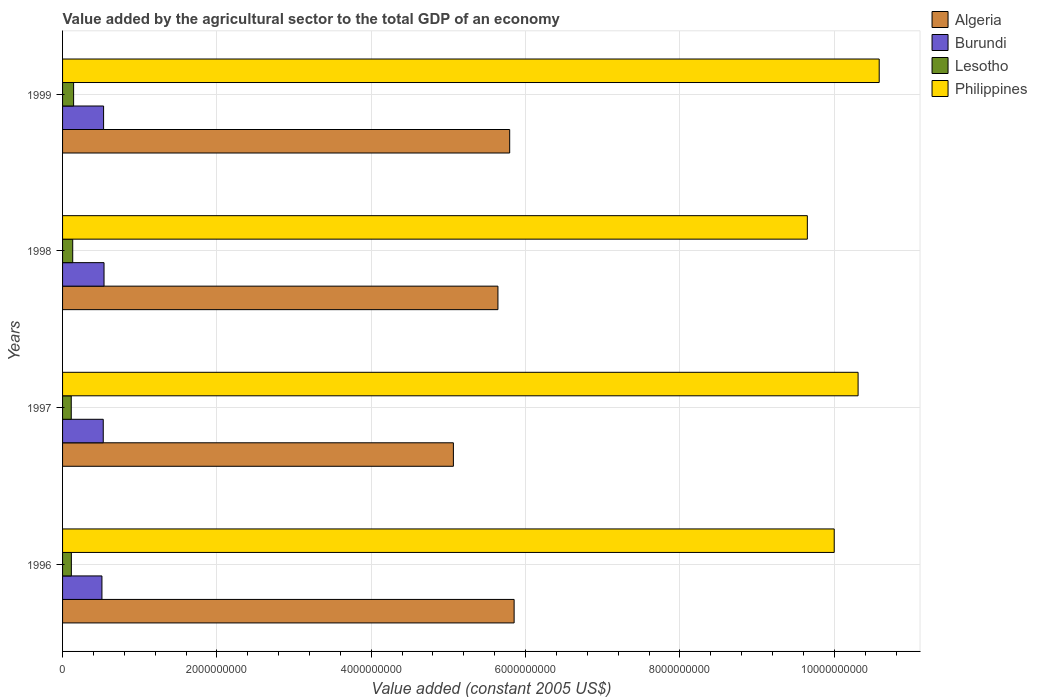How many groups of bars are there?
Provide a succinct answer. 4. Are the number of bars per tick equal to the number of legend labels?
Your response must be concise. Yes. Are the number of bars on each tick of the Y-axis equal?
Ensure brevity in your answer.  Yes. How many bars are there on the 4th tick from the top?
Your response must be concise. 4. How many bars are there on the 3rd tick from the bottom?
Provide a short and direct response. 4. What is the value added by the agricultural sector in Philippines in 1997?
Make the answer very short. 1.03e+1. Across all years, what is the maximum value added by the agricultural sector in Lesotho?
Your answer should be very brief. 1.43e+08. Across all years, what is the minimum value added by the agricultural sector in Philippines?
Provide a short and direct response. 9.65e+09. In which year was the value added by the agricultural sector in Burundi maximum?
Make the answer very short. 1998. What is the total value added by the agricultural sector in Burundi in the graph?
Provide a succinct answer. 2.11e+09. What is the difference between the value added by the agricultural sector in Algeria in 1996 and that in 1998?
Make the answer very short. 2.10e+08. What is the difference between the value added by the agricultural sector in Philippines in 1996 and the value added by the agricultural sector in Burundi in 1998?
Offer a very short reply. 9.46e+09. What is the average value added by the agricultural sector in Algeria per year?
Your answer should be compact. 5.59e+09. In the year 1998, what is the difference between the value added by the agricultural sector in Lesotho and value added by the agricultural sector in Burundi?
Keep it short and to the point. -4.06e+08. What is the ratio of the value added by the agricultural sector in Philippines in 1997 to that in 1998?
Your answer should be compact. 1.07. Is the value added by the agricultural sector in Algeria in 1996 less than that in 1999?
Keep it short and to the point. No. Is the difference between the value added by the agricultural sector in Lesotho in 1996 and 1999 greater than the difference between the value added by the agricultural sector in Burundi in 1996 and 1999?
Make the answer very short. No. What is the difference between the highest and the second highest value added by the agricultural sector in Philippines?
Offer a terse response. 2.74e+08. What is the difference between the highest and the lowest value added by the agricultural sector in Philippines?
Make the answer very short. 9.31e+08. In how many years, is the value added by the agricultural sector in Philippines greater than the average value added by the agricultural sector in Philippines taken over all years?
Offer a very short reply. 2. Is the sum of the value added by the agricultural sector in Burundi in 1997 and 1998 greater than the maximum value added by the agricultural sector in Lesotho across all years?
Provide a short and direct response. Yes. Is it the case that in every year, the sum of the value added by the agricultural sector in Burundi and value added by the agricultural sector in Philippines is greater than the sum of value added by the agricultural sector in Lesotho and value added by the agricultural sector in Algeria?
Make the answer very short. Yes. What does the 2nd bar from the top in 1997 represents?
Your answer should be very brief. Lesotho. What does the 1st bar from the bottom in 1998 represents?
Keep it short and to the point. Algeria. Is it the case that in every year, the sum of the value added by the agricultural sector in Philippines and value added by the agricultural sector in Burundi is greater than the value added by the agricultural sector in Lesotho?
Make the answer very short. Yes. How many years are there in the graph?
Offer a terse response. 4. What is the difference between two consecutive major ticks on the X-axis?
Make the answer very short. 2.00e+09. Are the values on the major ticks of X-axis written in scientific E-notation?
Provide a short and direct response. No. Where does the legend appear in the graph?
Keep it short and to the point. Top right. What is the title of the graph?
Your answer should be compact. Value added by the agricultural sector to the total GDP of an economy. Does "San Marino" appear as one of the legend labels in the graph?
Ensure brevity in your answer.  No. What is the label or title of the X-axis?
Offer a very short reply. Value added (constant 2005 US$). What is the Value added (constant 2005 US$) in Algeria in 1996?
Give a very brief answer. 5.85e+09. What is the Value added (constant 2005 US$) in Burundi in 1996?
Your answer should be compact. 5.10e+08. What is the Value added (constant 2005 US$) of Lesotho in 1996?
Offer a terse response. 1.14e+08. What is the Value added (constant 2005 US$) in Philippines in 1996?
Your response must be concise. 1.00e+1. What is the Value added (constant 2005 US$) of Algeria in 1997?
Offer a terse response. 5.06e+09. What is the Value added (constant 2005 US$) in Burundi in 1997?
Provide a short and direct response. 5.27e+08. What is the Value added (constant 2005 US$) in Lesotho in 1997?
Ensure brevity in your answer.  1.13e+08. What is the Value added (constant 2005 US$) in Philippines in 1997?
Your answer should be compact. 1.03e+1. What is the Value added (constant 2005 US$) in Algeria in 1998?
Provide a succinct answer. 5.64e+09. What is the Value added (constant 2005 US$) of Burundi in 1998?
Keep it short and to the point. 5.37e+08. What is the Value added (constant 2005 US$) in Lesotho in 1998?
Your answer should be compact. 1.32e+08. What is the Value added (constant 2005 US$) in Philippines in 1998?
Provide a short and direct response. 9.65e+09. What is the Value added (constant 2005 US$) in Algeria in 1999?
Offer a very short reply. 5.79e+09. What is the Value added (constant 2005 US$) in Burundi in 1999?
Give a very brief answer. 5.32e+08. What is the Value added (constant 2005 US$) of Lesotho in 1999?
Offer a terse response. 1.43e+08. What is the Value added (constant 2005 US$) of Philippines in 1999?
Give a very brief answer. 1.06e+1. Across all years, what is the maximum Value added (constant 2005 US$) in Algeria?
Give a very brief answer. 5.85e+09. Across all years, what is the maximum Value added (constant 2005 US$) of Burundi?
Provide a succinct answer. 5.37e+08. Across all years, what is the maximum Value added (constant 2005 US$) in Lesotho?
Keep it short and to the point. 1.43e+08. Across all years, what is the maximum Value added (constant 2005 US$) of Philippines?
Give a very brief answer. 1.06e+1. Across all years, what is the minimum Value added (constant 2005 US$) in Algeria?
Your answer should be very brief. 5.06e+09. Across all years, what is the minimum Value added (constant 2005 US$) in Burundi?
Your response must be concise. 5.10e+08. Across all years, what is the minimum Value added (constant 2005 US$) of Lesotho?
Offer a terse response. 1.13e+08. Across all years, what is the minimum Value added (constant 2005 US$) of Philippines?
Keep it short and to the point. 9.65e+09. What is the total Value added (constant 2005 US$) of Algeria in the graph?
Provide a succinct answer. 2.24e+1. What is the total Value added (constant 2005 US$) of Burundi in the graph?
Your answer should be very brief. 2.11e+09. What is the total Value added (constant 2005 US$) of Lesotho in the graph?
Offer a very short reply. 5.01e+08. What is the total Value added (constant 2005 US$) of Philippines in the graph?
Offer a very short reply. 4.05e+1. What is the difference between the Value added (constant 2005 US$) of Algeria in 1996 and that in 1997?
Your response must be concise. 7.87e+08. What is the difference between the Value added (constant 2005 US$) of Burundi in 1996 and that in 1997?
Your answer should be compact. -1.70e+07. What is the difference between the Value added (constant 2005 US$) of Lesotho in 1996 and that in 1997?
Give a very brief answer. 1.41e+06. What is the difference between the Value added (constant 2005 US$) in Philippines in 1996 and that in 1997?
Provide a succinct answer. -3.09e+08. What is the difference between the Value added (constant 2005 US$) of Algeria in 1996 and that in 1998?
Your answer should be compact. 2.10e+08. What is the difference between the Value added (constant 2005 US$) of Burundi in 1996 and that in 1998?
Offer a very short reply. -2.72e+07. What is the difference between the Value added (constant 2005 US$) in Lesotho in 1996 and that in 1998?
Offer a very short reply. -1.76e+07. What is the difference between the Value added (constant 2005 US$) in Philippines in 1996 and that in 1998?
Make the answer very short. 3.48e+08. What is the difference between the Value added (constant 2005 US$) in Algeria in 1996 and that in 1999?
Provide a short and direct response. 5.73e+07. What is the difference between the Value added (constant 2005 US$) in Burundi in 1996 and that in 1999?
Provide a succinct answer. -2.16e+07. What is the difference between the Value added (constant 2005 US$) in Lesotho in 1996 and that in 1999?
Ensure brevity in your answer.  -2.91e+07. What is the difference between the Value added (constant 2005 US$) in Philippines in 1996 and that in 1999?
Provide a succinct answer. -5.83e+08. What is the difference between the Value added (constant 2005 US$) in Algeria in 1997 and that in 1998?
Offer a terse response. -5.77e+08. What is the difference between the Value added (constant 2005 US$) in Burundi in 1997 and that in 1998?
Keep it short and to the point. -1.02e+07. What is the difference between the Value added (constant 2005 US$) of Lesotho in 1997 and that in 1998?
Ensure brevity in your answer.  -1.90e+07. What is the difference between the Value added (constant 2005 US$) of Philippines in 1997 and that in 1998?
Your answer should be compact. 6.58e+08. What is the difference between the Value added (constant 2005 US$) in Algeria in 1997 and that in 1999?
Provide a succinct answer. -7.30e+08. What is the difference between the Value added (constant 2005 US$) of Burundi in 1997 and that in 1999?
Give a very brief answer. -4.59e+06. What is the difference between the Value added (constant 2005 US$) of Lesotho in 1997 and that in 1999?
Provide a short and direct response. -3.05e+07. What is the difference between the Value added (constant 2005 US$) of Philippines in 1997 and that in 1999?
Provide a succinct answer. -2.74e+08. What is the difference between the Value added (constant 2005 US$) of Algeria in 1998 and that in 1999?
Provide a short and direct response. -1.52e+08. What is the difference between the Value added (constant 2005 US$) of Burundi in 1998 and that in 1999?
Provide a succinct answer. 5.59e+06. What is the difference between the Value added (constant 2005 US$) of Lesotho in 1998 and that in 1999?
Make the answer very short. -1.15e+07. What is the difference between the Value added (constant 2005 US$) of Philippines in 1998 and that in 1999?
Provide a short and direct response. -9.31e+08. What is the difference between the Value added (constant 2005 US$) in Algeria in 1996 and the Value added (constant 2005 US$) in Burundi in 1997?
Your answer should be compact. 5.32e+09. What is the difference between the Value added (constant 2005 US$) of Algeria in 1996 and the Value added (constant 2005 US$) of Lesotho in 1997?
Offer a very short reply. 5.74e+09. What is the difference between the Value added (constant 2005 US$) in Algeria in 1996 and the Value added (constant 2005 US$) in Philippines in 1997?
Make the answer very short. -4.46e+09. What is the difference between the Value added (constant 2005 US$) of Burundi in 1996 and the Value added (constant 2005 US$) of Lesotho in 1997?
Make the answer very short. 3.98e+08. What is the difference between the Value added (constant 2005 US$) in Burundi in 1996 and the Value added (constant 2005 US$) in Philippines in 1997?
Your answer should be compact. -9.80e+09. What is the difference between the Value added (constant 2005 US$) of Lesotho in 1996 and the Value added (constant 2005 US$) of Philippines in 1997?
Offer a terse response. -1.02e+1. What is the difference between the Value added (constant 2005 US$) in Algeria in 1996 and the Value added (constant 2005 US$) in Burundi in 1998?
Your answer should be compact. 5.31e+09. What is the difference between the Value added (constant 2005 US$) of Algeria in 1996 and the Value added (constant 2005 US$) of Lesotho in 1998?
Keep it short and to the point. 5.72e+09. What is the difference between the Value added (constant 2005 US$) of Algeria in 1996 and the Value added (constant 2005 US$) of Philippines in 1998?
Offer a very short reply. -3.80e+09. What is the difference between the Value added (constant 2005 US$) in Burundi in 1996 and the Value added (constant 2005 US$) in Lesotho in 1998?
Your answer should be very brief. 3.79e+08. What is the difference between the Value added (constant 2005 US$) of Burundi in 1996 and the Value added (constant 2005 US$) of Philippines in 1998?
Ensure brevity in your answer.  -9.14e+09. What is the difference between the Value added (constant 2005 US$) of Lesotho in 1996 and the Value added (constant 2005 US$) of Philippines in 1998?
Provide a succinct answer. -9.54e+09. What is the difference between the Value added (constant 2005 US$) of Algeria in 1996 and the Value added (constant 2005 US$) of Burundi in 1999?
Provide a short and direct response. 5.32e+09. What is the difference between the Value added (constant 2005 US$) of Algeria in 1996 and the Value added (constant 2005 US$) of Lesotho in 1999?
Give a very brief answer. 5.71e+09. What is the difference between the Value added (constant 2005 US$) of Algeria in 1996 and the Value added (constant 2005 US$) of Philippines in 1999?
Provide a short and direct response. -4.73e+09. What is the difference between the Value added (constant 2005 US$) in Burundi in 1996 and the Value added (constant 2005 US$) in Lesotho in 1999?
Your response must be concise. 3.67e+08. What is the difference between the Value added (constant 2005 US$) of Burundi in 1996 and the Value added (constant 2005 US$) of Philippines in 1999?
Give a very brief answer. -1.01e+1. What is the difference between the Value added (constant 2005 US$) in Lesotho in 1996 and the Value added (constant 2005 US$) in Philippines in 1999?
Offer a very short reply. -1.05e+1. What is the difference between the Value added (constant 2005 US$) in Algeria in 1997 and the Value added (constant 2005 US$) in Burundi in 1998?
Your answer should be very brief. 4.53e+09. What is the difference between the Value added (constant 2005 US$) of Algeria in 1997 and the Value added (constant 2005 US$) of Lesotho in 1998?
Offer a very short reply. 4.93e+09. What is the difference between the Value added (constant 2005 US$) in Algeria in 1997 and the Value added (constant 2005 US$) in Philippines in 1998?
Offer a terse response. -4.59e+09. What is the difference between the Value added (constant 2005 US$) in Burundi in 1997 and the Value added (constant 2005 US$) in Lesotho in 1998?
Your answer should be compact. 3.96e+08. What is the difference between the Value added (constant 2005 US$) of Burundi in 1997 and the Value added (constant 2005 US$) of Philippines in 1998?
Provide a succinct answer. -9.12e+09. What is the difference between the Value added (constant 2005 US$) in Lesotho in 1997 and the Value added (constant 2005 US$) in Philippines in 1998?
Your answer should be very brief. -9.54e+09. What is the difference between the Value added (constant 2005 US$) in Algeria in 1997 and the Value added (constant 2005 US$) in Burundi in 1999?
Your response must be concise. 4.53e+09. What is the difference between the Value added (constant 2005 US$) in Algeria in 1997 and the Value added (constant 2005 US$) in Lesotho in 1999?
Offer a terse response. 4.92e+09. What is the difference between the Value added (constant 2005 US$) in Algeria in 1997 and the Value added (constant 2005 US$) in Philippines in 1999?
Your answer should be compact. -5.52e+09. What is the difference between the Value added (constant 2005 US$) of Burundi in 1997 and the Value added (constant 2005 US$) of Lesotho in 1999?
Offer a terse response. 3.84e+08. What is the difference between the Value added (constant 2005 US$) of Burundi in 1997 and the Value added (constant 2005 US$) of Philippines in 1999?
Your response must be concise. -1.01e+1. What is the difference between the Value added (constant 2005 US$) of Lesotho in 1997 and the Value added (constant 2005 US$) of Philippines in 1999?
Offer a very short reply. -1.05e+1. What is the difference between the Value added (constant 2005 US$) of Algeria in 1998 and the Value added (constant 2005 US$) of Burundi in 1999?
Make the answer very short. 5.11e+09. What is the difference between the Value added (constant 2005 US$) in Algeria in 1998 and the Value added (constant 2005 US$) in Lesotho in 1999?
Provide a succinct answer. 5.50e+09. What is the difference between the Value added (constant 2005 US$) in Algeria in 1998 and the Value added (constant 2005 US$) in Philippines in 1999?
Your answer should be very brief. -4.94e+09. What is the difference between the Value added (constant 2005 US$) in Burundi in 1998 and the Value added (constant 2005 US$) in Lesotho in 1999?
Give a very brief answer. 3.94e+08. What is the difference between the Value added (constant 2005 US$) in Burundi in 1998 and the Value added (constant 2005 US$) in Philippines in 1999?
Offer a very short reply. -1.00e+1. What is the difference between the Value added (constant 2005 US$) of Lesotho in 1998 and the Value added (constant 2005 US$) of Philippines in 1999?
Your response must be concise. -1.05e+1. What is the average Value added (constant 2005 US$) of Algeria per year?
Provide a succinct answer. 5.59e+09. What is the average Value added (constant 2005 US$) of Burundi per year?
Offer a terse response. 5.27e+08. What is the average Value added (constant 2005 US$) in Lesotho per year?
Your answer should be compact. 1.25e+08. What is the average Value added (constant 2005 US$) in Philippines per year?
Make the answer very short. 1.01e+1. In the year 1996, what is the difference between the Value added (constant 2005 US$) of Algeria and Value added (constant 2005 US$) of Burundi?
Provide a short and direct response. 5.34e+09. In the year 1996, what is the difference between the Value added (constant 2005 US$) in Algeria and Value added (constant 2005 US$) in Lesotho?
Offer a very short reply. 5.74e+09. In the year 1996, what is the difference between the Value added (constant 2005 US$) of Algeria and Value added (constant 2005 US$) of Philippines?
Ensure brevity in your answer.  -4.15e+09. In the year 1996, what is the difference between the Value added (constant 2005 US$) in Burundi and Value added (constant 2005 US$) in Lesotho?
Your answer should be very brief. 3.96e+08. In the year 1996, what is the difference between the Value added (constant 2005 US$) in Burundi and Value added (constant 2005 US$) in Philippines?
Your answer should be compact. -9.49e+09. In the year 1996, what is the difference between the Value added (constant 2005 US$) in Lesotho and Value added (constant 2005 US$) in Philippines?
Your answer should be compact. -9.89e+09. In the year 1997, what is the difference between the Value added (constant 2005 US$) of Algeria and Value added (constant 2005 US$) of Burundi?
Give a very brief answer. 4.54e+09. In the year 1997, what is the difference between the Value added (constant 2005 US$) of Algeria and Value added (constant 2005 US$) of Lesotho?
Your answer should be very brief. 4.95e+09. In the year 1997, what is the difference between the Value added (constant 2005 US$) in Algeria and Value added (constant 2005 US$) in Philippines?
Offer a very short reply. -5.24e+09. In the year 1997, what is the difference between the Value added (constant 2005 US$) in Burundi and Value added (constant 2005 US$) in Lesotho?
Keep it short and to the point. 4.14e+08. In the year 1997, what is the difference between the Value added (constant 2005 US$) of Burundi and Value added (constant 2005 US$) of Philippines?
Your answer should be compact. -9.78e+09. In the year 1997, what is the difference between the Value added (constant 2005 US$) in Lesotho and Value added (constant 2005 US$) in Philippines?
Offer a terse response. -1.02e+1. In the year 1998, what is the difference between the Value added (constant 2005 US$) of Algeria and Value added (constant 2005 US$) of Burundi?
Keep it short and to the point. 5.10e+09. In the year 1998, what is the difference between the Value added (constant 2005 US$) in Algeria and Value added (constant 2005 US$) in Lesotho?
Your answer should be very brief. 5.51e+09. In the year 1998, what is the difference between the Value added (constant 2005 US$) in Algeria and Value added (constant 2005 US$) in Philippines?
Your answer should be very brief. -4.01e+09. In the year 1998, what is the difference between the Value added (constant 2005 US$) of Burundi and Value added (constant 2005 US$) of Lesotho?
Make the answer very short. 4.06e+08. In the year 1998, what is the difference between the Value added (constant 2005 US$) of Burundi and Value added (constant 2005 US$) of Philippines?
Give a very brief answer. -9.11e+09. In the year 1998, what is the difference between the Value added (constant 2005 US$) in Lesotho and Value added (constant 2005 US$) in Philippines?
Your answer should be compact. -9.52e+09. In the year 1999, what is the difference between the Value added (constant 2005 US$) of Algeria and Value added (constant 2005 US$) of Burundi?
Your answer should be very brief. 5.26e+09. In the year 1999, what is the difference between the Value added (constant 2005 US$) in Algeria and Value added (constant 2005 US$) in Lesotho?
Provide a short and direct response. 5.65e+09. In the year 1999, what is the difference between the Value added (constant 2005 US$) of Algeria and Value added (constant 2005 US$) of Philippines?
Provide a succinct answer. -4.79e+09. In the year 1999, what is the difference between the Value added (constant 2005 US$) in Burundi and Value added (constant 2005 US$) in Lesotho?
Your answer should be compact. 3.89e+08. In the year 1999, what is the difference between the Value added (constant 2005 US$) of Burundi and Value added (constant 2005 US$) of Philippines?
Your answer should be very brief. -1.01e+1. In the year 1999, what is the difference between the Value added (constant 2005 US$) of Lesotho and Value added (constant 2005 US$) of Philippines?
Ensure brevity in your answer.  -1.04e+1. What is the ratio of the Value added (constant 2005 US$) in Algeria in 1996 to that in 1997?
Offer a terse response. 1.16. What is the ratio of the Value added (constant 2005 US$) in Burundi in 1996 to that in 1997?
Your response must be concise. 0.97. What is the ratio of the Value added (constant 2005 US$) in Lesotho in 1996 to that in 1997?
Keep it short and to the point. 1.01. What is the ratio of the Value added (constant 2005 US$) of Algeria in 1996 to that in 1998?
Provide a short and direct response. 1.04. What is the ratio of the Value added (constant 2005 US$) of Burundi in 1996 to that in 1998?
Offer a terse response. 0.95. What is the ratio of the Value added (constant 2005 US$) of Lesotho in 1996 to that in 1998?
Offer a very short reply. 0.87. What is the ratio of the Value added (constant 2005 US$) in Philippines in 1996 to that in 1998?
Your answer should be very brief. 1.04. What is the ratio of the Value added (constant 2005 US$) of Algeria in 1996 to that in 1999?
Your answer should be very brief. 1.01. What is the ratio of the Value added (constant 2005 US$) in Burundi in 1996 to that in 1999?
Your answer should be compact. 0.96. What is the ratio of the Value added (constant 2005 US$) in Lesotho in 1996 to that in 1999?
Make the answer very short. 0.8. What is the ratio of the Value added (constant 2005 US$) in Philippines in 1996 to that in 1999?
Your response must be concise. 0.94. What is the ratio of the Value added (constant 2005 US$) in Algeria in 1997 to that in 1998?
Provide a short and direct response. 0.9. What is the ratio of the Value added (constant 2005 US$) in Burundi in 1997 to that in 1998?
Provide a short and direct response. 0.98. What is the ratio of the Value added (constant 2005 US$) in Lesotho in 1997 to that in 1998?
Provide a short and direct response. 0.86. What is the ratio of the Value added (constant 2005 US$) in Philippines in 1997 to that in 1998?
Provide a short and direct response. 1.07. What is the ratio of the Value added (constant 2005 US$) in Algeria in 1997 to that in 1999?
Offer a terse response. 0.87. What is the ratio of the Value added (constant 2005 US$) of Lesotho in 1997 to that in 1999?
Give a very brief answer. 0.79. What is the ratio of the Value added (constant 2005 US$) in Philippines in 1997 to that in 1999?
Ensure brevity in your answer.  0.97. What is the ratio of the Value added (constant 2005 US$) of Algeria in 1998 to that in 1999?
Ensure brevity in your answer.  0.97. What is the ratio of the Value added (constant 2005 US$) of Burundi in 1998 to that in 1999?
Keep it short and to the point. 1.01. What is the ratio of the Value added (constant 2005 US$) of Lesotho in 1998 to that in 1999?
Offer a terse response. 0.92. What is the ratio of the Value added (constant 2005 US$) in Philippines in 1998 to that in 1999?
Provide a short and direct response. 0.91. What is the difference between the highest and the second highest Value added (constant 2005 US$) of Algeria?
Ensure brevity in your answer.  5.73e+07. What is the difference between the highest and the second highest Value added (constant 2005 US$) in Burundi?
Give a very brief answer. 5.59e+06. What is the difference between the highest and the second highest Value added (constant 2005 US$) of Lesotho?
Offer a very short reply. 1.15e+07. What is the difference between the highest and the second highest Value added (constant 2005 US$) of Philippines?
Ensure brevity in your answer.  2.74e+08. What is the difference between the highest and the lowest Value added (constant 2005 US$) of Algeria?
Provide a short and direct response. 7.87e+08. What is the difference between the highest and the lowest Value added (constant 2005 US$) in Burundi?
Keep it short and to the point. 2.72e+07. What is the difference between the highest and the lowest Value added (constant 2005 US$) of Lesotho?
Your response must be concise. 3.05e+07. What is the difference between the highest and the lowest Value added (constant 2005 US$) in Philippines?
Offer a very short reply. 9.31e+08. 